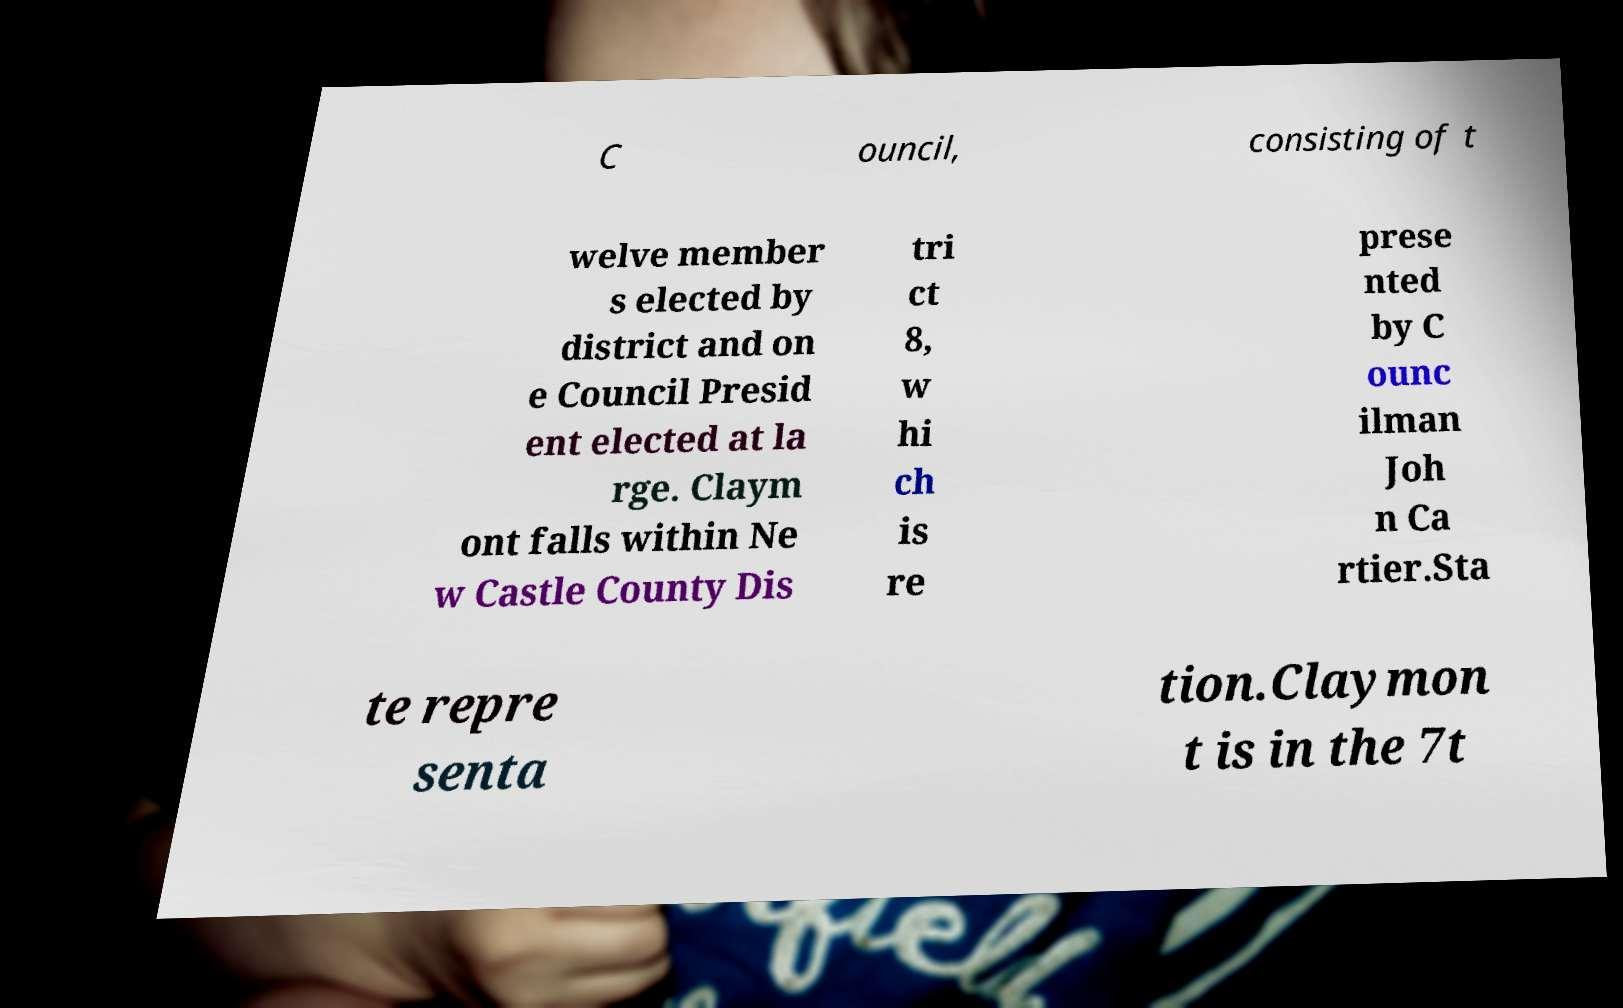What messages or text are displayed in this image? I need them in a readable, typed format. C ouncil, consisting of t welve member s elected by district and on e Council Presid ent elected at la rge. Claym ont falls within Ne w Castle County Dis tri ct 8, w hi ch is re prese nted by C ounc ilman Joh n Ca rtier.Sta te repre senta tion.Claymon t is in the 7t 